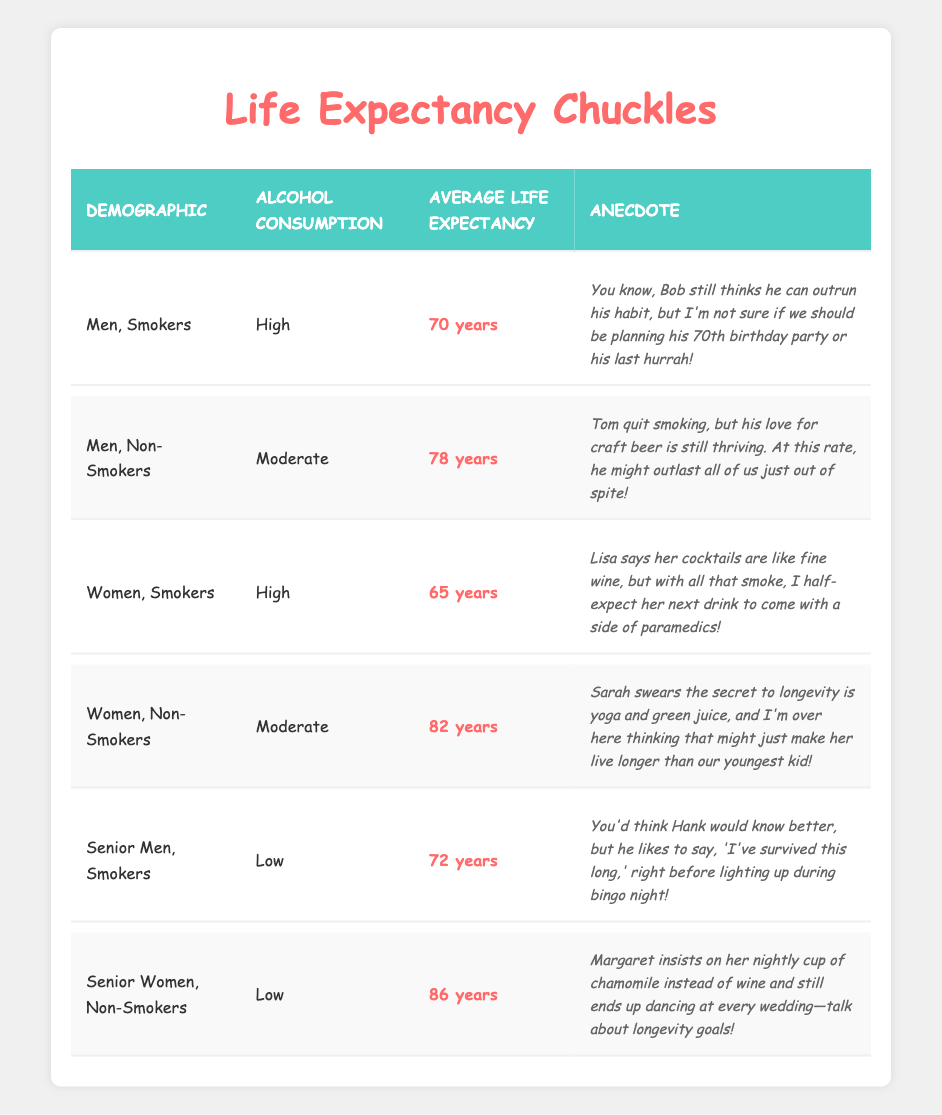What is the average life expectancy for women who smoke and consume alcohol at a high level? The necessary data point for "Women, Smokers" with high alcohol consumption indicates an average life expectancy of 65 years.
Answer: 65 years What demographic has the highest average life expectancy according to the table? Analyzing the data points, "Senior Women, Non-Smokers" have the highest average life expectancy at 86 years.
Answer: 86 years How much longer do non-smoking women live on average compared to smoking women? First, we find the average life expectancy for non-smoking women (82 years) and smoking women (65 years). The difference is 82 - 65 = 17 years, so non-smoking women live an average of 17 years longer.
Answer: 17 years Is it true that all smokers in the table have a life expectancy lower than non-smokers? If we check each smoker's data: Men Smokers (70 years), Women Smokers (65 years), and Senior Men Smokers (72 years) all have lower life expectancies compared to their non-smoking counterparts (Men Non-Smokers at 78 years and Senior Women Non-Smokers at 86 years). This confirms the statement to be true.
Answer: Yes What is the difference in average life expectancy between men and women who do not smoke and consume alcohol at a moderate level? For "Men, Non-Smokers," the average life expectancy is 78 years, while for "Women, Non-Smokers," it is 82 years. The difference is 82 - 78 = 4 years, so women live 4 years longer on average than men in this category.
Answer: 4 years 